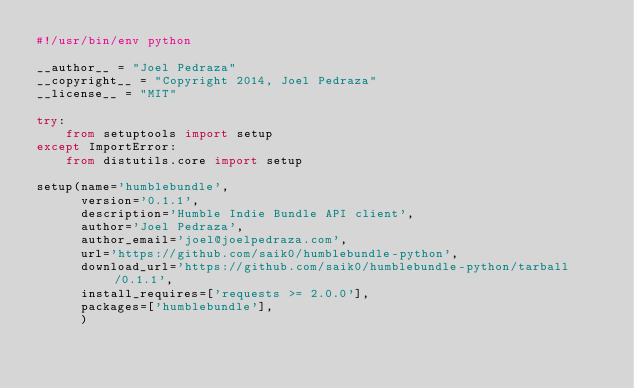<code> <loc_0><loc_0><loc_500><loc_500><_Python_>#!/usr/bin/env python

__author__ = "Joel Pedraza"
__copyright__ = "Copyright 2014, Joel Pedraza"
__license__ = "MIT"

try:
    from setuptools import setup
except ImportError:
    from distutils.core import setup

setup(name='humblebundle',
      version='0.1.1',
      description='Humble Indie Bundle API client',
      author='Joel Pedraza',
      author_email='joel@joelpedraza.com',
      url='https://github.com/saik0/humblebundle-python',
      download_url='https://github.com/saik0/humblebundle-python/tarball/0.1.1',
      install_requires=['requests >= 2.0.0'],
      packages=['humblebundle'],
      )
</code> 